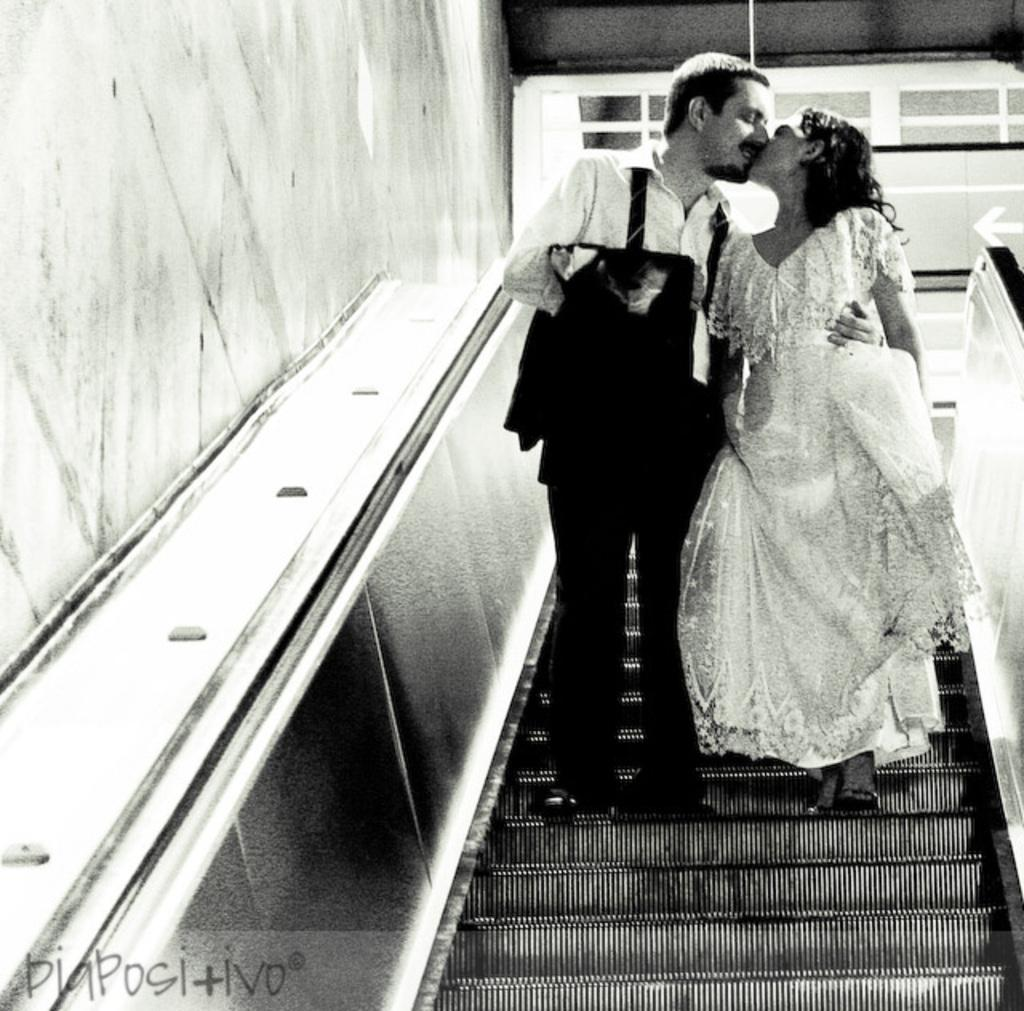What is the color scheme of the image? The image is black and white. Who are the people in the image? There is a man and a woman in the image. Where are the man and woman located in the image? The man and woman are standing on an escalator. What are the man and woman doing in the image? The man and woman are kissing each other. What type of plate is being used by the man and woman in the image? There is no plate present in the image; it features a man and a woman standing on an escalator and kissing each other. 